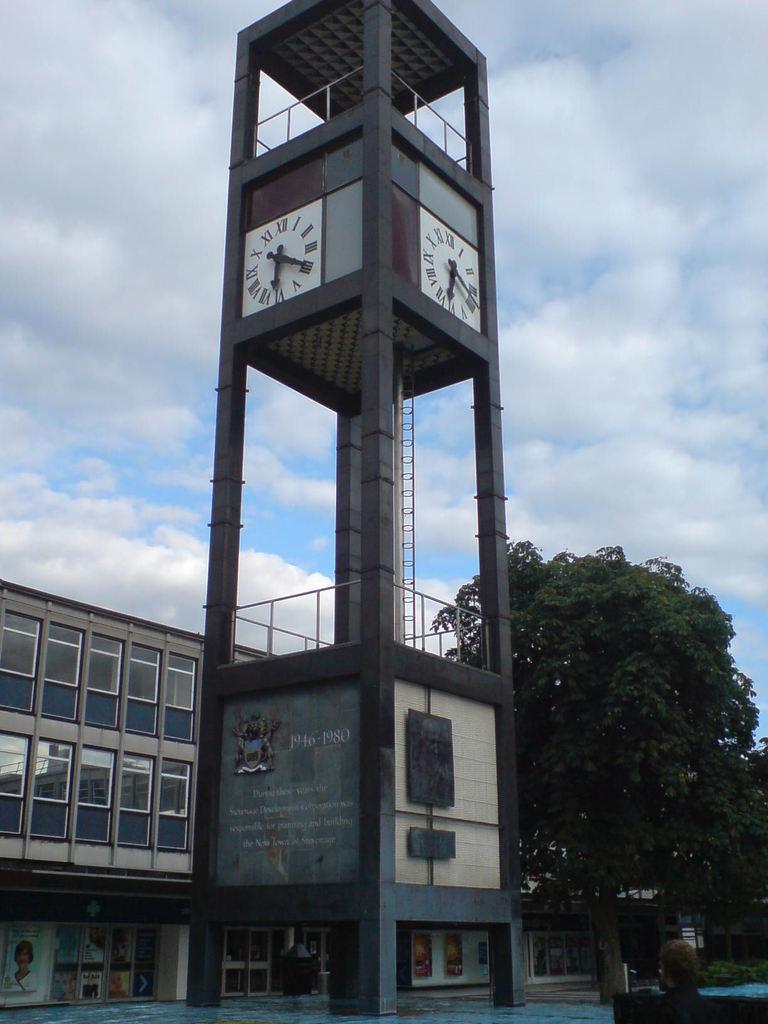Could you give a brief overview of what you see in this image? In this picture we can see a tower on the ground, on this tower we can see clocks on it, at the back of tower we can see a building, where we can see a person, trees, plants and we can see sky in the background. 